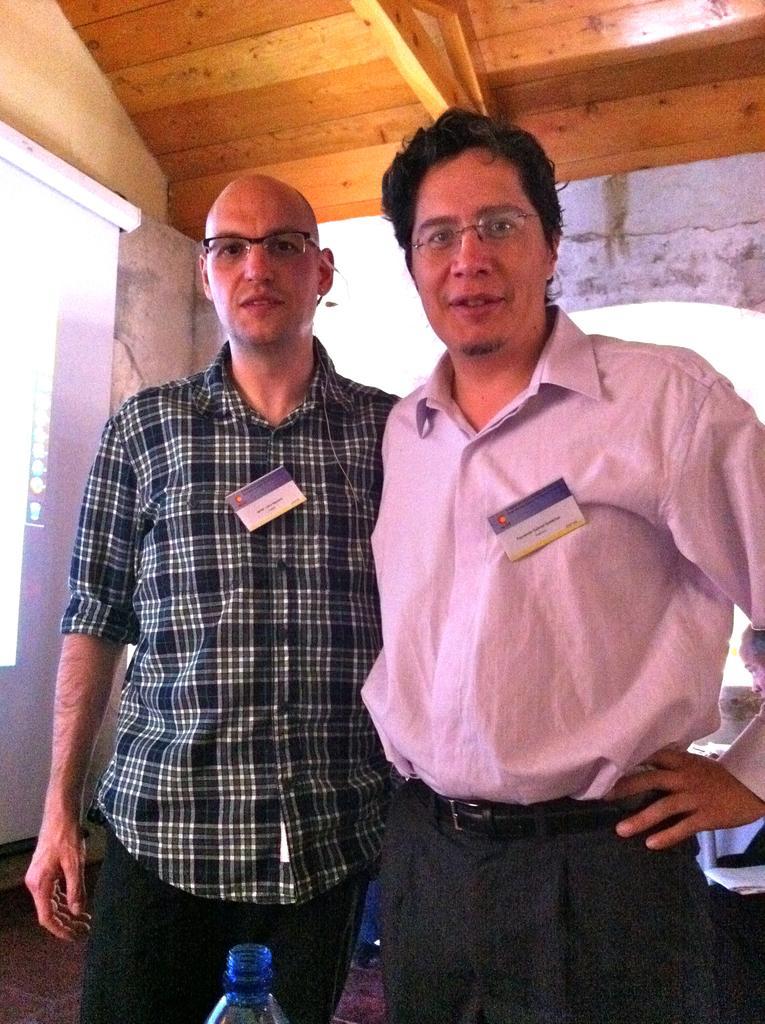How would you summarize this image in a sentence or two? In this picture we can see two men standing here, they wore spectacles, at the bottom there is a bottle, in the background we can see a screen, there is a wooden ceiling at the top of the picture. 